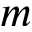<formula> <loc_0><loc_0><loc_500><loc_500>m</formula> 